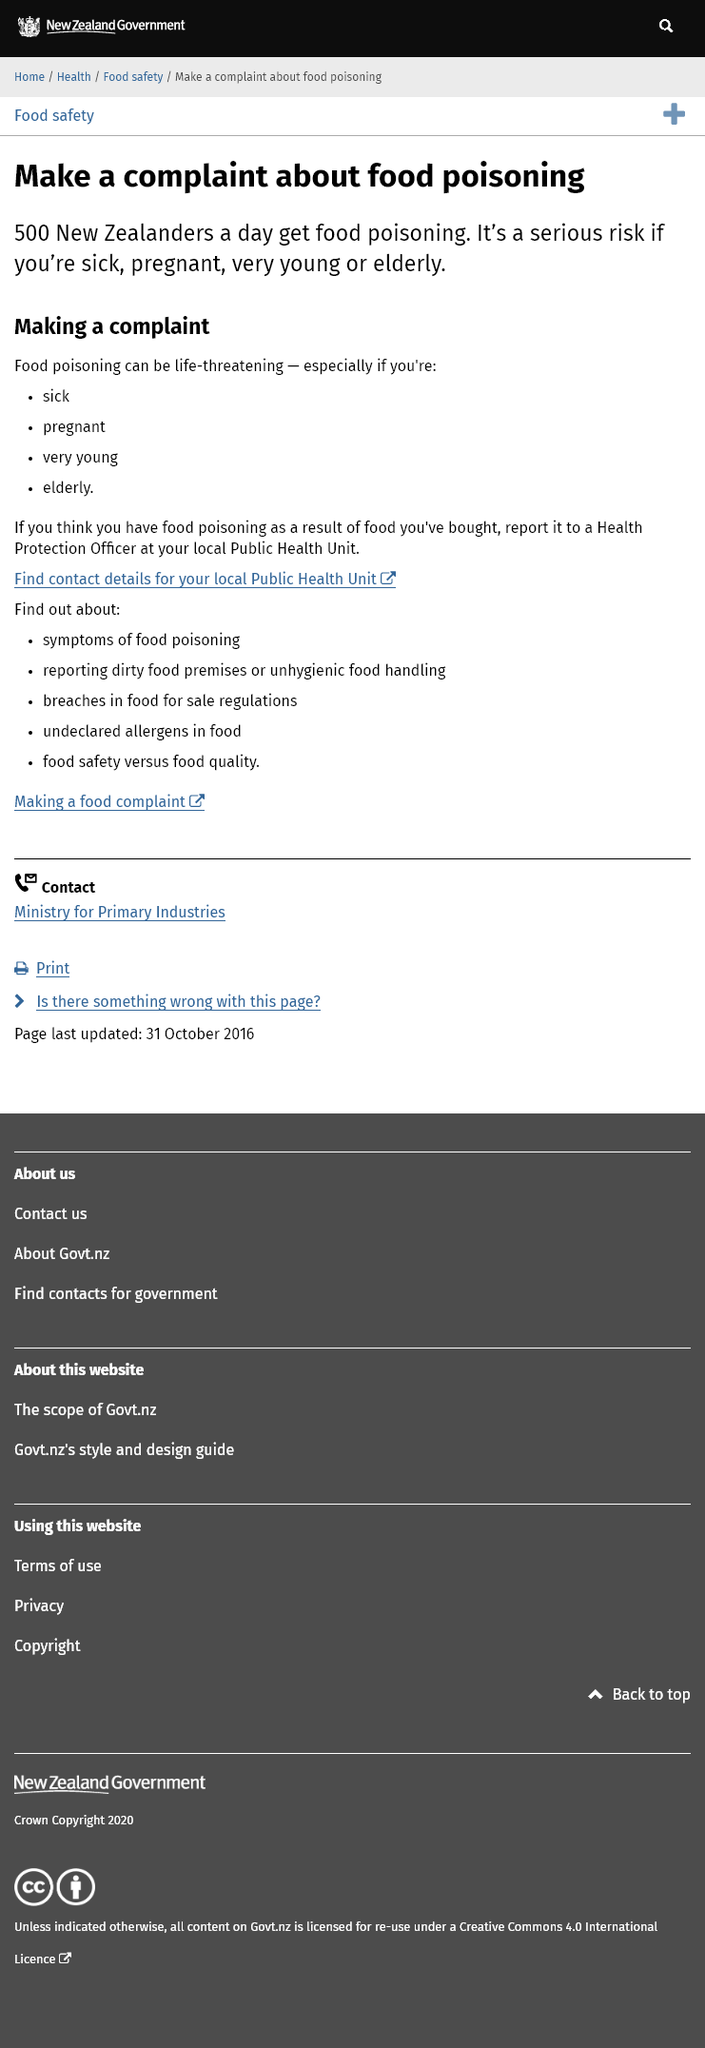Outline some significant characteristics in this image. It is estimated that on average, approximately 500 New Zealanders suffer from food poisoning every day. The sick, elderly, pregnant, and very young are the four groups who are most vulnerable to the risk of death if they contract food poisoning. If you suspect that you have food poisoning from food that you have purchased, you should report it to a Health Protection Officer immediately. 